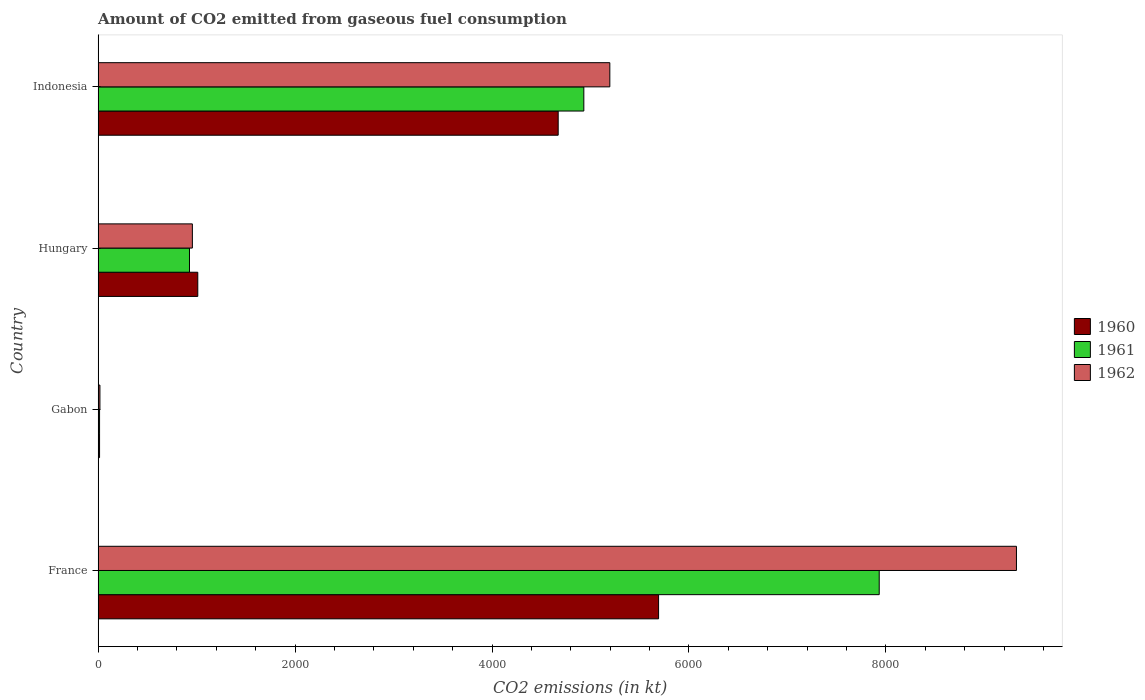How many groups of bars are there?
Provide a short and direct response. 4. Are the number of bars per tick equal to the number of legend labels?
Offer a very short reply. Yes. What is the label of the 2nd group of bars from the top?
Your answer should be very brief. Hungary. What is the amount of CO2 emitted in 1960 in France?
Give a very brief answer. 5691.18. Across all countries, what is the maximum amount of CO2 emitted in 1961?
Provide a short and direct response. 7931.72. Across all countries, what is the minimum amount of CO2 emitted in 1960?
Provide a succinct answer. 14.67. In which country was the amount of CO2 emitted in 1961 minimum?
Your response must be concise. Gabon. What is the total amount of CO2 emitted in 1960 in the graph?
Your answer should be very brief. 1.14e+04. What is the difference between the amount of CO2 emitted in 1961 in France and that in Indonesia?
Ensure brevity in your answer.  2999.61. What is the difference between the amount of CO2 emitted in 1960 in France and the amount of CO2 emitted in 1961 in Hungary?
Make the answer very short. 4763.43. What is the average amount of CO2 emitted in 1962 per country?
Ensure brevity in your answer.  3874.19. What is the difference between the amount of CO2 emitted in 1961 and amount of CO2 emitted in 1960 in France?
Keep it short and to the point. 2240.54. What is the ratio of the amount of CO2 emitted in 1960 in France to that in Indonesia?
Offer a very short reply. 1.22. Is the difference between the amount of CO2 emitted in 1961 in Gabon and Indonesia greater than the difference between the amount of CO2 emitted in 1960 in Gabon and Indonesia?
Your answer should be very brief. No. What is the difference between the highest and the second highest amount of CO2 emitted in 1961?
Provide a short and direct response. 2999.61. What is the difference between the highest and the lowest amount of CO2 emitted in 1960?
Offer a terse response. 5676.52. What does the 2nd bar from the top in Indonesia represents?
Make the answer very short. 1961. What does the 2nd bar from the bottom in Hungary represents?
Keep it short and to the point. 1961. Is it the case that in every country, the sum of the amount of CO2 emitted in 1962 and amount of CO2 emitted in 1960 is greater than the amount of CO2 emitted in 1961?
Give a very brief answer. Yes. How many countries are there in the graph?
Ensure brevity in your answer.  4. Are the values on the major ticks of X-axis written in scientific E-notation?
Your answer should be compact. No. Does the graph contain any zero values?
Give a very brief answer. No. Does the graph contain grids?
Keep it short and to the point. No. How many legend labels are there?
Make the answer very short. 3. How are the legend labels stacked?
Make the answer very short. Vertical. What is the title of the graph?
Keep it short and to the point. Amount of CO2 emitted from gaseous fuel consumption. Does "1974" appear as one of the legend labels in the graph?
Offer a terse response. No. What is the label or title of the X-axis?
Keep it short and to the point. CO2 emissions (in kt). What is the label or title of the Y-axis?
Your answer should be compact. Country. What is the CO2 emissions (in kt) of 1960 in France?
Your answer should be very brief. 5691.18. What is the CO2 emissions (in kt) of 1961 in France?
Offer a very short reply. 7931.72. What is the CO2 emissions (in kt) of 1962 in France?
Your answer should be compact. 9325.18. What is the CO2 emissions (in kt) in 1960 in Gabon?
Offer a terse response. 14.67. What is the CO2 emissions (in kt) in 1961 in Gabon?
Your answer should be compact. 14.67. What is the CO2 emissions (in kt) in 1962 in Gabon?
Make the answer very short. 18.34. What is the CO2 emissions (in kt) of 1960 in Hungary?
Make the answer very short. 1012.09. What is the CO2 emissions (in kt) in 1961 in Hungary?
Provide a succinct answer. 927.75. What is the CO2 emissions (in kt) of 1962 in Hungary?
Provide a short and direct response. 957.09. What is the CO2 emissions (in kt) of 1960 in Indonesia?
Your answer should be very brief. 4671.76. What is the CO2 emissions (in kt) of 1961 in Indonesia?
Your response must be concise. 4932.11. What is the CO2 emissions (in kt) of 1962 in Indonesia?
Keep it short and to the point. 5196.14. Across all countries, what is the maximum CO2 emissions (in kt) of 1960?
Ensure brevity in your answer.  5691.18. Across all countries, what is the maximum CO2 emissions (in kt) in 1961?
Your answer should be compact. 7931.72. Across all countries, what is the maximum CO2 emissions (in kt) of 1962?
Keep it short and to the point. 9325.18. Across all countries, what is the minimum CO2 emissions (in kt) in 1960?
Keep it short and to the point. 14.67. Across all countries, what is the minimum CO2 emissions (in kt) in 1961?
Keep it short and to the point. 14.67. Across all countries, what is the minimum CO2 emissions (in kt) of 1962?
Provide a succinct answer. 18.34. What is the total CO2 emissions (in kt) of 1960 in the graph?
Offer a terse response. 1.14e+04. What is the total CO2 emissions (in kt) in 1961 in the graph?
Ensure brevity in your answer.  1.38e+04. What is the total CO2 emissions (in kt) in 1962 in the graph?
Keep it short and to the point. 1.55e+04. What is the difference between the CO2 emissions (in kt) of 1960 in France and that in Gabon?
Provide a succinct answer. 5676.52. What is the difference between the CO2 emissions (in kt) of 1961 in France and that in Gabon?
Keep it short and to the point. 7917.05. What is the difference between the CO2 emissions (in kt) in 1962 in France and that in Gabon?
Provide a short and direct response. 9306.85. What is the difference between the CO2 emissions (in kt) in 1960 in France and that in Hungary?
Make the answer very short. 4679.09. What is the difference between the CO2 emissions (in kt) of 1961 in France and that in Hungary?
Your response must be concise. 7003.97. What is the difference between the CO2 emissions (in kt) in 1962 in France and that in Hungary?
Provide a short and direct response. 8368.09. What is the difference between the CO2 emissions (in kt) of 1960 in France and that in Indonesia?
Give a very brief answer. 1019.43. What is the difference between the CO2 emissions (in kt) of 1961 in France and that in Indonesia?
Make the answer very short. 2999.61. What is the difference between the CO2 emissions (in kt) of 1962 in France and that in Indonesia?
Ensure brevity in your answer.  4129.04. What is the difference between the CO2 emissions (in kt) in 1960 in Gabon and that in Hungary?
Provide a short and direct response. -997.42. What is the difference between the CO2 emissions (in kt) of 1961 in Gabon and that in Hungary?
Offer a terse response. -913.08. What is the difference between the CO2 emissions (in kt) of 1962 in Gabon and that in Hungary?
Give a very brief answer. -938.75. What is the difference between the CO2 emissions (in kt) of 1960 in Gabon and that in Indonesia?
Offer a terse response. -4657.09. What is the difference between the CO2 emissions (in kt) in 1961 in Gabon and that in Indonesia?
Make the answer very short. -4917.45. What is the difference between the CO2 emissions (in kt) in 1962 in Gabon and that in Indonesia?
Provide a succinct answer. -5177.8. What is the difference between the CO2 emissions (in kt) in 1960 in Hungary and that in Indonesia?
Keep it short and to the point. -3659.67. What is the difference between the CO2 emissions (in kt) in 1961 in Hungary and that in Indonesia?
Your answer should be compact. -4004.36. What is the difference between the CO2 emissions (in kt) of 1962 in Hungary and that in Indonesia?
Offer a terse response. -4239.05. What is the difference between the CO2 emissions (in kt) of 1960 in France and the CO2 emissions (in kt) of 1961 in Gabon?
Provide a short and direct response. 5676.52. What is the difference between the CO2 emissions (in kt) in 1960 in France and the CO2 emissions (in kt) in 1962 in Gabon?
Provide a succinct answer. 5672.85. What is the difference between the CO2 emissions (in kt) of 1961 in France and the CO2 emissions (in kt) of 1962 in Gabon?
Your answer should be compact. 7913.39. What is the difference between the CO2 emissions (in kt) in 1960 in France and the CO2 emissions (in kt) in 1961 in Hungary?
Provide a short and direct response. 4763.43. What is the difference between the CO2 emissions (in kt) in 1960 in France and the CO2 emissions (in kt) in 1962 in Hungary?
Make the answer very short. 4734.1. What is the difference between the CO2 emissions (in kt) of 1961 in France and the CO2 emissions (in kt) of 1962 in Hungary?
Your response must be concise. 6974.63. What is the difference between the CO2 emissions (in kt) in 1960 in France and the CO2 emissions (in kt) in 1961 in Indonesia?
Give a very brief answer. 759.07. What is the difference between the CO2 emissions (in kt) of 1960 in France and the CO2 emissions (in kt) of 1962 in Indonesia?
Provide a short and direct response. 495.05. What is the difference between the CO2 emissions (in kt) of 1961 in France and the CO2 emissions (in kt) of 1962 in Indonesia?
Make the answer very short. 2735.58. What is the difference between the CO2 emissions (in kt) in 1960 in Gabon and the CO2 emissions (in kt) in 1961 in Hungary?
Give a very brief answer. -913.08. What is the difference between the CO2 emissions (in kt) of 1960 in Gabon and the CO2 emissions (in kt) of 1962 in Hungary?
Keep it short and to the point. -942.42. What is the difference between the CO2 emissions (in kt) in 1961 in Gabon and the CO2 emissions (in kt) in 1962 in Hungary?
Offer a terse response. -942.42. What is the difference between the CO2 emissions (in kt) of 1960 in Gabon and the CO2 emissions (in kt) of 1961 in Indonesia?
Your response must be concise. -4917.45. What is the difference between the CO2 emissions (in kt) in 1960 in Gabon and the CO2 emissions (in kt) in 1962 in Indonesia?
Keep it short and to the point. -5181.47. What is the difference between the CO2 emissions (in kt) of 1961 in Gabon and the CO2 emissions (in kt) of 1962 in Indonesia?
Give a very brief answer. -5181.47. What is the difference between the CO2 emissions (in kt) in 1960 in Hungary and the CO2 emissions (in kt) in 1961 in Indonesia?
Your answer should be compact. -3920.02. What is the difference between the CO2 emissions (in kt) of 1960 in Hungary and the CO2 emissions (in kt) of 1962 in Indonesia?
Provide a short and direct response. -4184.05. What is the difference between the CO2 emissions (in kt) of 1961 in Hungary and the CO2 emissions (in kt) of 1962 in Indonesia?
Your answer should be very brief. -4268.39. What is the average CO2 emissions (in kt) of 1960 per country?
Ensure brevity in your answer.  2847.43. What is the average CO2 emissions (in kt) in 1961 per country?
Your response must be concise. 3451.56. What is the average CO2 emissions (in kt) in 1962 per country?
Your response must be concise. 3874.19. What is the difference between the CO2 emissions (in kt) of 1960 and CO2 emissions (in kt) of 1961 in France?
Your answer should be very brief. -2240.54. What is the difference between the CO2 emissions (in kt) of 1960 and CO2 emissions (in kt) of 1962 in France?
Provide a succinct answer. -3634. What is the difference between the CO2 emissions (in kt) in 1961 and CO2 emissions (in kt) in 1962 in France?
Your answer should be compact. -1393.46. What is the difference between the CO2 emissions (in kt) in 1960 and CO2 emissions (in kt) in 1962 in Gabon?
Offer a very short reply. -3.67. What is the difference between the CO2 emissions (in kt) in 1961 and CO2 emissions (in kt) in 1962 in Gabon?
Provide a succinct answer. -3.67. What is the difference between the CO2 emissions (in kt) of 1960 and CO2 emissions (in kt) of 1961 in Hungary?
Provide a short and direct response. 84.34. What is the difference between the CO2 emissions (in kt) of 1960 and CO2 emissions (in kt) of 1962 in Hungary?
Offer a terse response. 55.01. What is the difference between the CO2 emissions (in kt) of 1961 and CO2 emissions (in kt) of 1962 in Hungary?
Offer a very short reply. -29.34. What is the difference between the CO2 emissions (in kt) of 1960 and CO2 emissions (in kt) of 1961 in Indonesia?
Make the answer very short. -260.36. What is the difference between the CO2 emissions (in kt) in 1960 and CO2 emissions (in kt) in 1962 in Indonesia?
Provide a short and direct response. -524.38. What is the difference between the CO2 emissions (in kt) of 1961 and CO2 emissions (in kt) of 1962 in Indonesia?
Your answer should be very brief. -264.02. What is the ratio of the CO2 emissions (in kt) of 1960 in France to that in Gabon?
Provide a short and direct response. 388. What is the ratio of the CO2 emissions (in kt) in 1961 in France to that in Gabon?
Offer a terse response. 540.75. What is the ratio of the CO2 emissions (in kt) of 1962 in France to that in Gabon?
Provide a short and direct response. 508.6. What is the ratio of the CO2 emissions (in kt) of 1960 in France to that in Hungary?
Provide a short and direct response. 5.62. What is the ratio of the CO2 emissions (in kt) in 1961 in France to that in Hungary?
Ensure brevity in your answer.  8.55. What is the ratio of the CO2 emissions (in kt) of 1962 in France to that in Hungary?
Your answer should be very brief. 9.74. What is the ratio of the CO2 emissions (in kt) of 1960 in France to that in Indonesia?
Give a very brief answer. 1.22. What is the ratio of the CO2 emissions (in kt) of 1961 in France to that in Indonesia?
Provide a short and direct response. 1.61. What is the ratio of the CO2 emissions (in kt) in 1962 in France to that in Indonesia?
Your response must be concise. 1.79. What is the ratio of the CO2 emissions (in kt) in 1960 in Gabon to that in Hungary?
Provide a succinct answer. 0.01. What is the ratio of the CO2 emissions (in kt) in 1961 in Gabon to that in Hungary?
Your response must be concise. 0.02. What is the ratio of the CO2 emissions (in kt) of 1962 in Gabon to that in Hungary?
Offer a terse response. 0.02. What is the ratio of the CO2 emissions (in kt) in 1960 in Gabon to that in Indonesia?
Provide a short and direct response. 0. What is the ratio of the CO2 emissions (in kt) of 1961 in Gabon to that in Indonesia?
Your answer should be very brief. 0. What is the ratio of the CO2 emissions (in kt) in 1962 in Gabon to that in Indonesia?
Give a very brief answer. 0. What is the ratio of the CO2 emissions (in kt) of 1960 in Hungary to that in Indonesia?
Your response must be concise. 0.22. What is the ratio of the CO2 emissions (in kt) of 1961 in Hungary to that in Indonesia?
Your answer should be very brief. 0.19. What is the ratio of the CO2 emissions (in kt) in 1962 in Hungary to that in Indonesia?
Provide a succinct answer. 0.18. What is the difference between the highest and the second highest CO2 emissions (in kt) of 1960?
Keep it short and to the point. 1019.43. What is the difference between the highest and the second highest CO2 emissions (in kt) in 1961?
Your answer should be compact. 2999.61. What is the difference between the highest and the second highest CO2 emissions (in kt) in 1962?
Your answer should be compact. 4129.04. What is the difference between the highest and the lowest CO2 emissions (in kt) of 1960?
Offer a terse response. 5676.52. What is the difference between the highest and the lowest CO2 emissions (in kt) in 1961?
Offer a very short reply. 7917.05. What is the difference between the highest and the lowest CO2 emissions (in kt) in 1962?
Your response must be concise. 9306.85. 